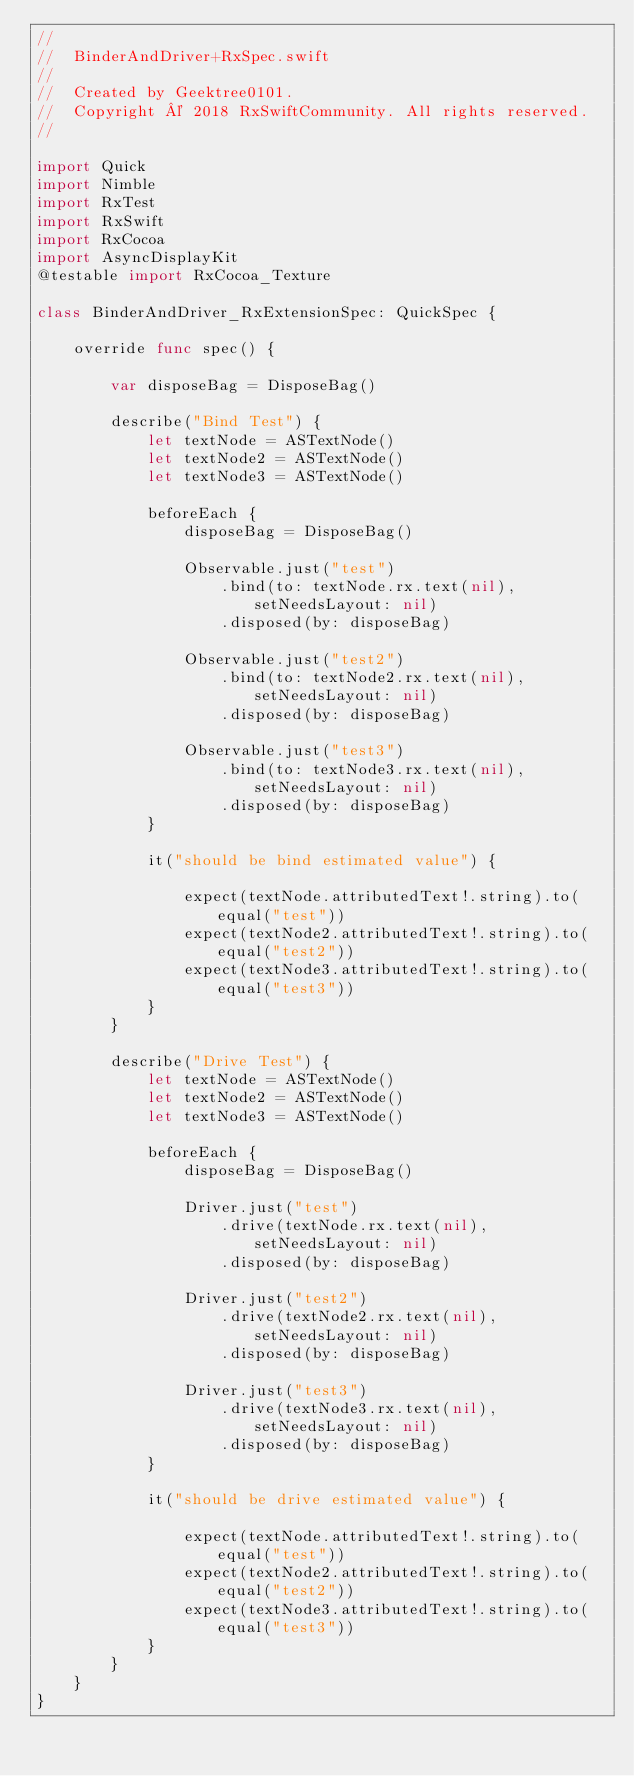<code> <loc_0><loc_0><loc_500><loc_500><_Swift_>//
//  BinderAndDriver+RxSpec.swift
//
//  Created by Geektree0101.
//  Copyright © 2018 RxSwiftCommunity. All rights reserved.
//

import Quick
import Nimble
import RxTest
import RxSwift
import RxCocoa
import AsyncDisplayKit
@testable import RxCocoa_Texture

class BinderAndDriver_RxExtensionSpec: QuickSpec {
    
    override func spec() {
        
        var disposeBag = DisposeBag()
        
        describe("Bind Test") {
            let textNode = ASTextNode()
            let textNode2 = ASTextNode()
            let textNode3 = ASTextNode()
            
            beforeEach {
                disposeBag = DisposeBag()
                
                Observable.just("test")
                    .bind(to: textNode.rx.text(nil), setNeedsLayout: nil)
                    .disposed(by: disposeBag)
                
                Observable.just("test2")
                    .bind(to: textNode2.rx.text(nil), setNeedsLayout: nil)
                    .disposed(by: disposeBag)
                
                Observable.just("test3")
                    .bind(to: textNode3.rx.text(nil), setNeedsLayout: nil)
                    .disposed(by: disposeBag)
            }
            
            it("should be bind estimated value") {
                
                expect(textNode.attributedText!.string).to(equal("test"))
                expect(textNode2.attributedText!.string).to(equal("test2"))
                expect(textNode3.attributedText!.string).to(equal("test3"))
            }
        }
        
        describe("Drive Test") {
            let textNode = ASTextNode()
            let textNode2 = ASTextNode()
            let textNode3 = ASTextNode()
            
            beforeEach {
                disposeBag = DisposeBag()
                
                Driver.just("test")
                    .drive(textNode.rx.text(nil), setNeedsLayout: nil)
                    .disposed(by: disposeBag)
                
                Driver.just("test2")
                    .drive(textNode2.rx.text(nil), setNeedsLayout: nil)
                    .disposed(by: disposeBag)
                
                Driver.just("test3")
                    .drive(textNode3.rx.text(nil), setNeedsLayout: nil)
                    .disposed(by: disposeBag)
            }
            
            it("should be drive estimated value") {
                
                expect(textNode.attributedText!.string).to(equal("test"))
                expect(textNode2.attributedText!.string).to(equal("test2"))
                expect(textNode3.attributedText!.string).to(equal("test3"))
            }
        }
    }
}
</code> 